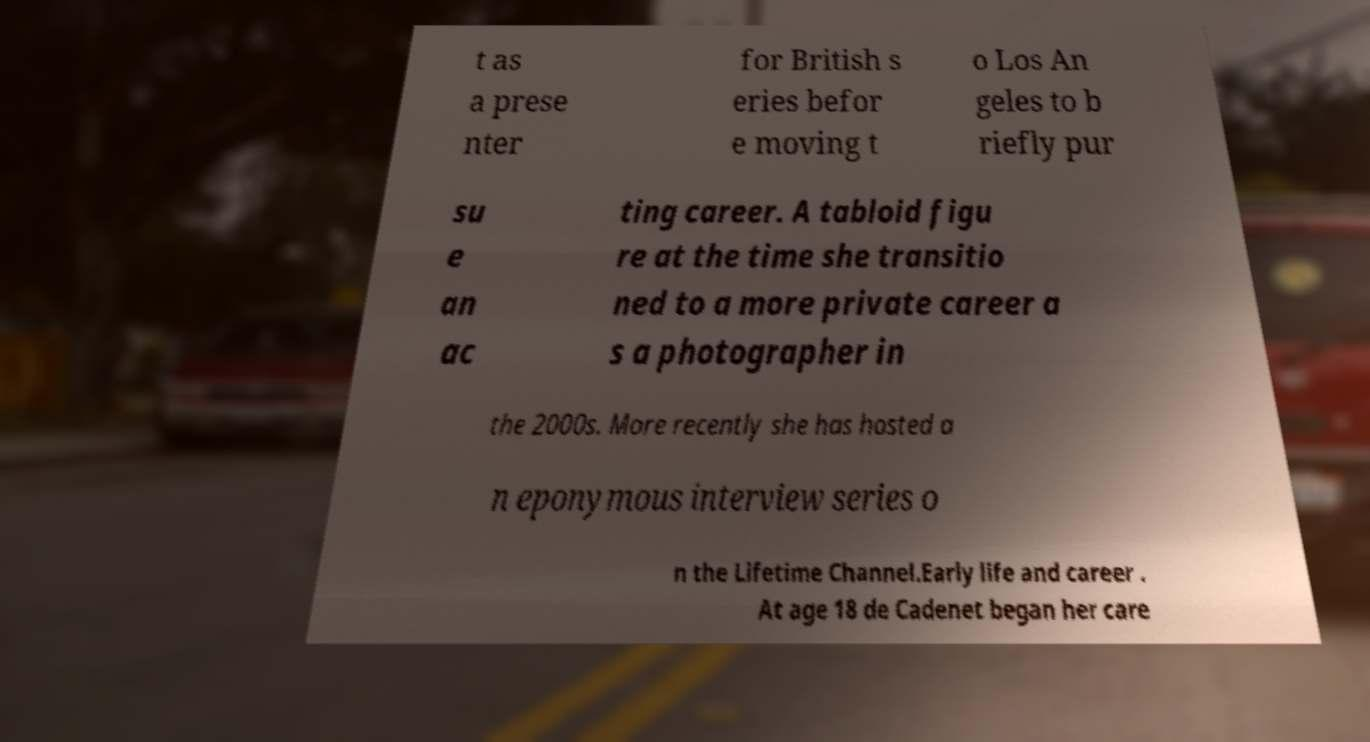For documentation purposes, I need the text within this image transcribed. Could you provide that? t as a prese nter for British s eries befor e moving t o Los An geles to b riefly pur su e an ac ting career. A tabloid figu re at the time she transitio ned to a more private career a s a photographer in the 2000s. More recently she has hosted a n eponymous interview series o n the Lifetime Channel.Early life and career . At age 18 de Cadenet began her care 